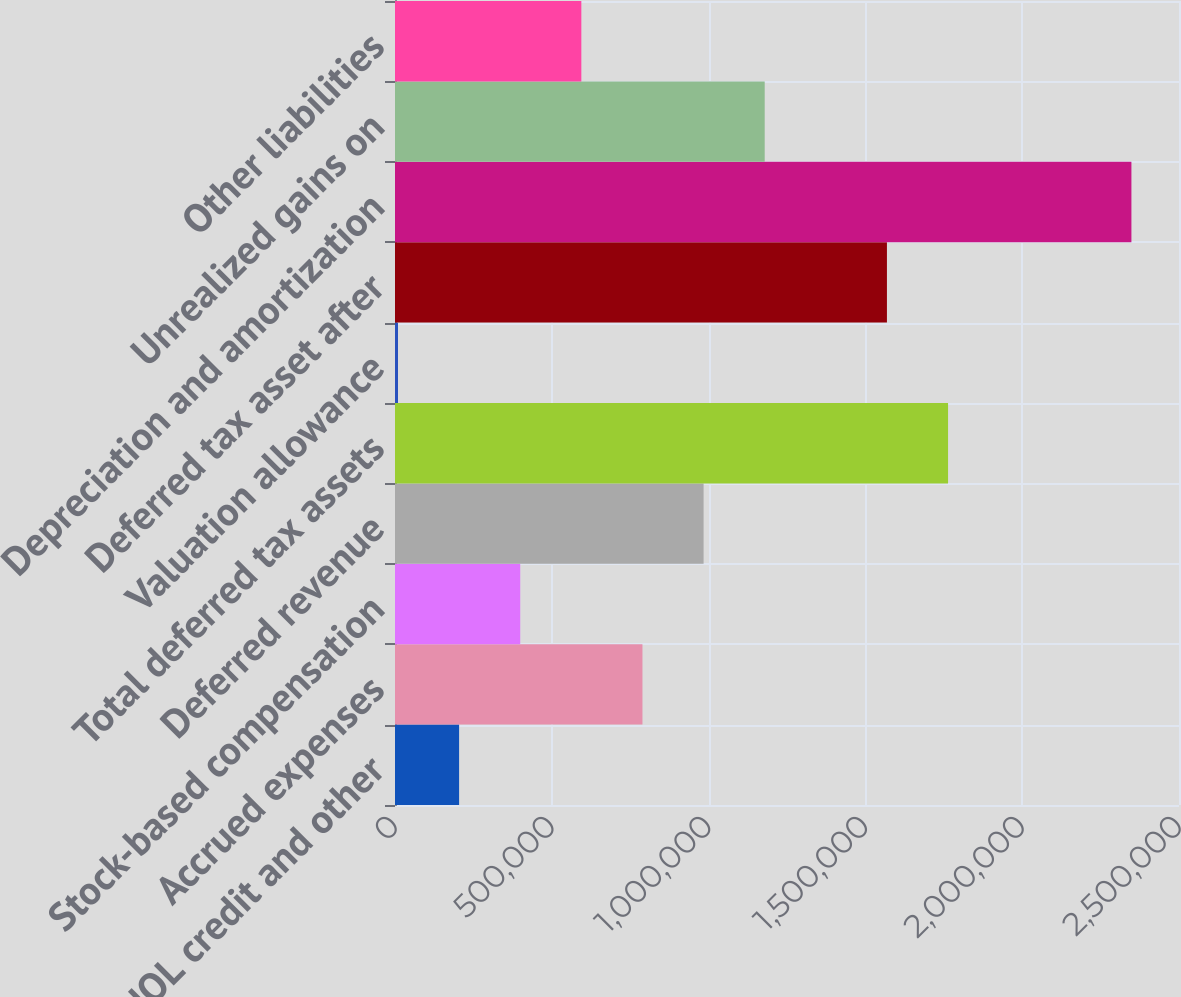Convert chart. <chart><loc_0><loc_0><loc_500><loc_500><bar_chart><fcel>NOL credit and other<fcel>Accrued expenses<fcel>Stock-based compensation<fcel>Deferred revenue<fcel>Total deferred tax assets<fcel>Valuation allowance<fcel>Deferred tax asset after<fcel>Depreciation and amortization<fcel>Unrealized gains on<fcel>Other liabilities<nl><fcel>204410<fcel>789094<fcel>399304<fcel>983988<fcel>1.76357e+06<fcel>9515<fcel>1.56867e+06<fcel>2.34825e+06<fcel>1.17888e+06<fcel>594199<nl></chart> 